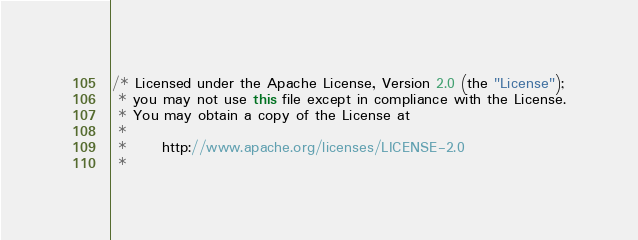Convert code to text. <code><loc_0><loc_0><loc_500><loc_500><_Java_>/* Licensed under the Apache License, Version 2.0 (the "License");
 * you may not use this file except in compliance with the License.
 * You may obtain a copy of the License at
 * 
 *      http://www.apache.org/licenses/LICENSE-2.0
 * </code> 